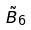Convert formula to latex. <formula><loc_0><loc_0><loc_500><loc_500>\tilde { B } _ { 6 }</formula> 